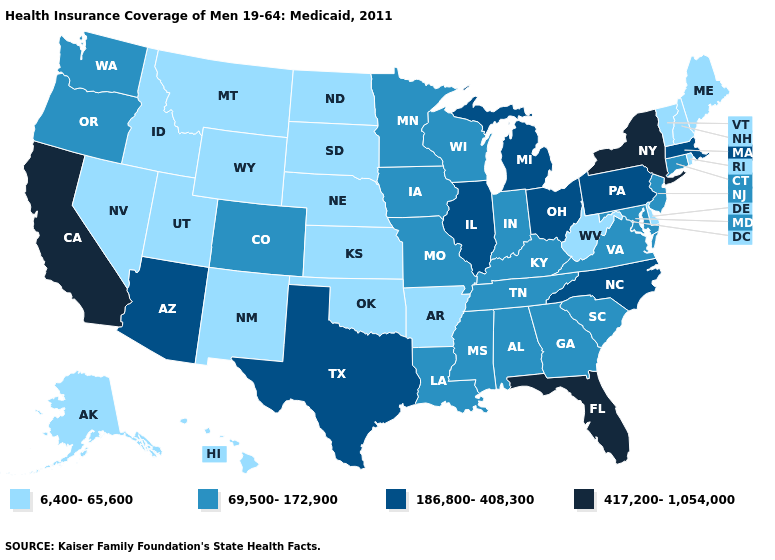Name the states that have a value in the range 417,200-1,054,000?
Keep it brief. California, Florida, New York. Among the states that border Tennessee , does North Carolina have the highest value?
Answer briefly. Yes. Name the states that have a value in the range 6,400-65,600?
Be succinct. Alaska, Arkansas, Delaware, Hawaii, Idaho, Kansas, Maine, Montana, Nebraska, Nevada, New Hampshire, New Mexico, North Dakota, Oklahoma, Rhode Island, South Dakota, Utah, Vermont, West Virginia, Wyoming. What is the highest value in states that border Kansas?
Answer briefly. 69,500-172,900. Among the states that border Indiana , which have the lowest value?
Short answer required. Kentucky. Name the states that have a value in the range 186,800-408,300?
Concise answer only. Arizona, Illinois, Massachusetts, Michigan, North Carolina, Ohio, Pennsylvania, Texas. What is the lowest value in the Northeast?
Keep it brief. 6,400-65,600. What is the value of Rhode Island?
Write a very short answer. 6,400-65,600. Does the first symbol in the legend represent the smallest category?
Short answer required. Yes. What is the value of New York?
Write a very short answer. 417,200-1,054,000. Which states hav the highest value in the West?
Give a very brief answer. California. What is the value of Kentucky?
Concise answer only. 69,500-172,900. Which states have the highest value in the USA?
Answer briefly. California, Florida, New York. What is the value of North Carolina?
Quick response, please. 186,800-408,300. What is the lowest value in the Northeast?
Keep it brief. 6,400-65,600. 